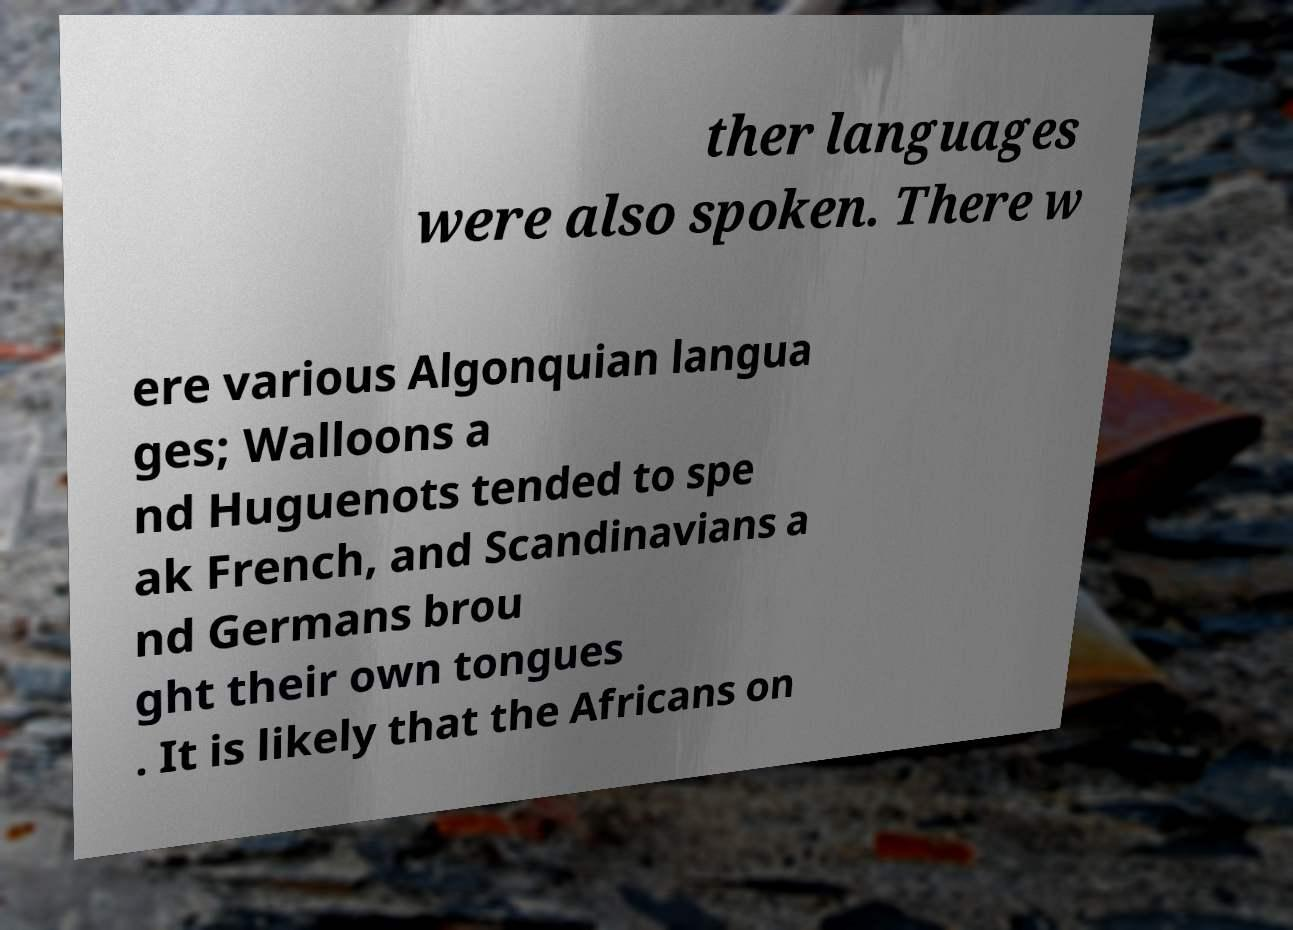Please read and relay the text visible in this image. What does it say? ther languages were also spoken. There w ere various Algonquian langua ges; Walloons a nd Huguenots tended to spe ak French, and Scandinavians a nd Germans brou ght their own tongues . It is likely that the Africans on 